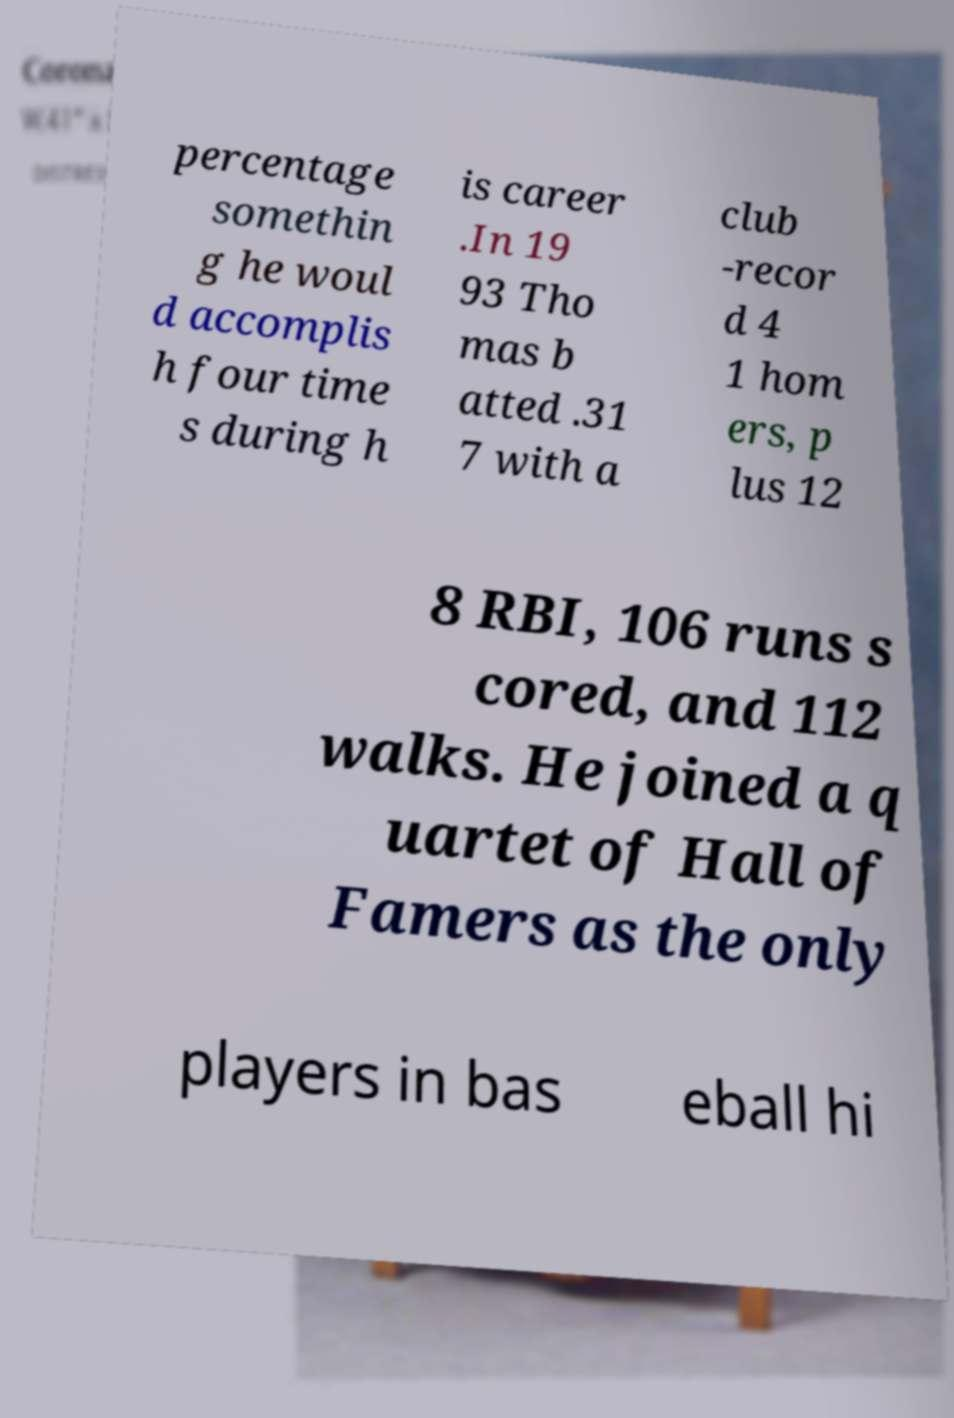Can you accurately transcribe the text from the provided image for me? percentage somethin g he woul d accomplis h four time s during h is career .In 19 93 Tho mas b atted .31 7 with a club -recor d 4 1 hom ers, p lus 12 8 RBI, 106 runs s cored, and 112 walks. He joined a q uartet of Hall of Famers as the only players in bas eball hi 